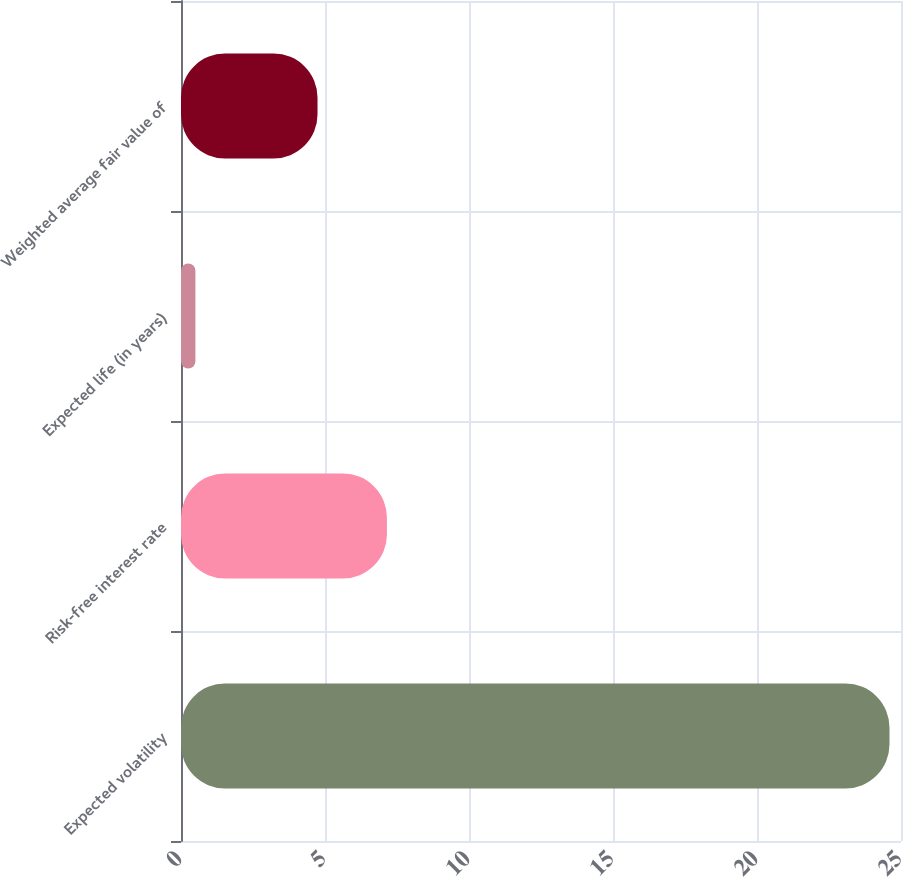<chart> <loc_0><loc_0><loc_500><loc_500><bar_chart><fcel>Expected volatility<fcel>Risk-free interest rate<fcel>Expected life (in years)<fcel>Weighted average fair value of<nl><fcel>24.6<fcel>7.15<fcel>0.5<fcel>4.74<nl></chart> 